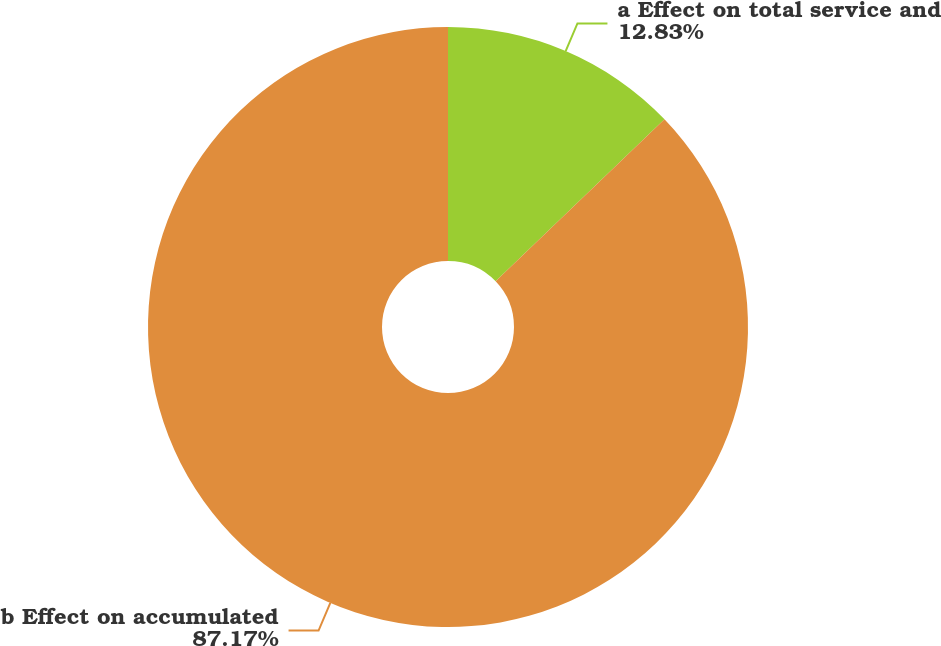Convert chart. <chart><loc_0><loc_0><loc_500><loc_500><pie_chart><fcel>a Effect on total service and<fcel>b Effect on accumulated<nl><fcel>12.83%<fcel>87.17%<nl></chart> 